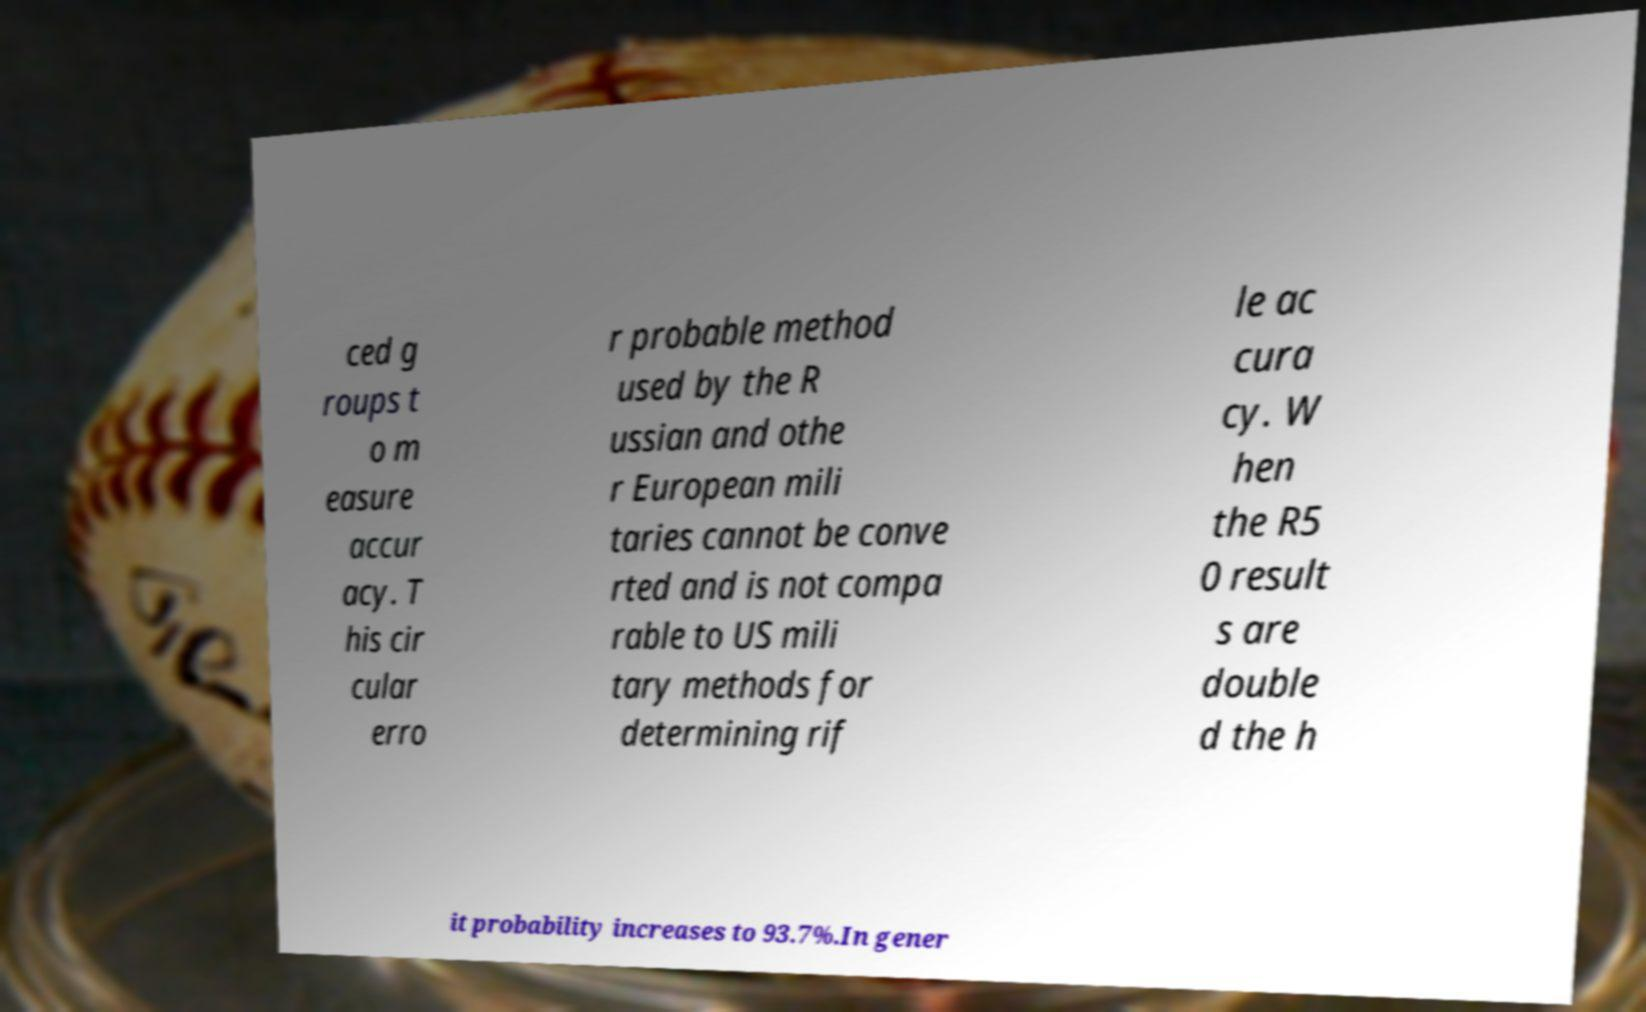I need the written content from this picture converted into text. Can you do that? ced g roups t o m easure accur acy. T his cir cular erro r probable method used by the R ussian and othe r European mili taries cannot be conve rted and is not compa rable to US mili tary methods for determining rif le ac cura cy. W hen the R5 0 result s are double d the h it probability increases to 93.7%.In gener 